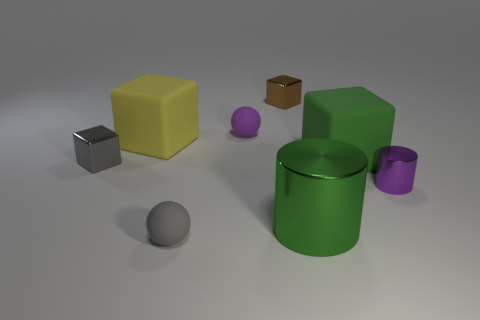Subtract all gray shiny blocks. How many blocks are left? 3 Add 1 small gray spheres. How many objects exist? 9 Subtract all green cylinders. How many cylinders are left? 1 Subtract all cylinders. How many objects are left? 6 Subtract 0 red cylinders. How many objects are left? 8 Subtract 1 balls. How many balls are left? 1 Subtract all purple cubes. Subtract all purple cylinders. How many cubes are left? 4 Subtract all red blocks. How many yellow balls are left? 0 Subtract all yellow blocks. Subtract all small gray blocks. How many objects are left? 6 Add 5 green cubes. How many green cubes are left? 6 